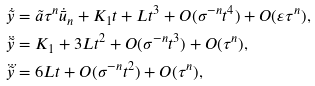<formula> <loc_0><loc_0><loc_500><loc_500>\dot { \tilde { y } } & = \tilde { a } \tau ^ { n } \dot { \bar { u } } _ { n } + K _ { 1 } t + L t ^ { 3 } + O ( \sigma ^ { - n } t ^ { 4 } ) + O ( \varepsilon \tau ^ { n } ) , \\ \ddot { \tilde { y } } & = K _ { 1 } + 3 L t ^ { 2 } + O ( \sigma ^ { - n } t ^ { 3 } ) + O ( \tau ^ { n } ) , \\ \dddot { \tilde { y } } & = 6 L t + O ( \sigma ^ { - n } t ^ { 2 } ) + O ( \tau ^ { n } ) ,</formula> 